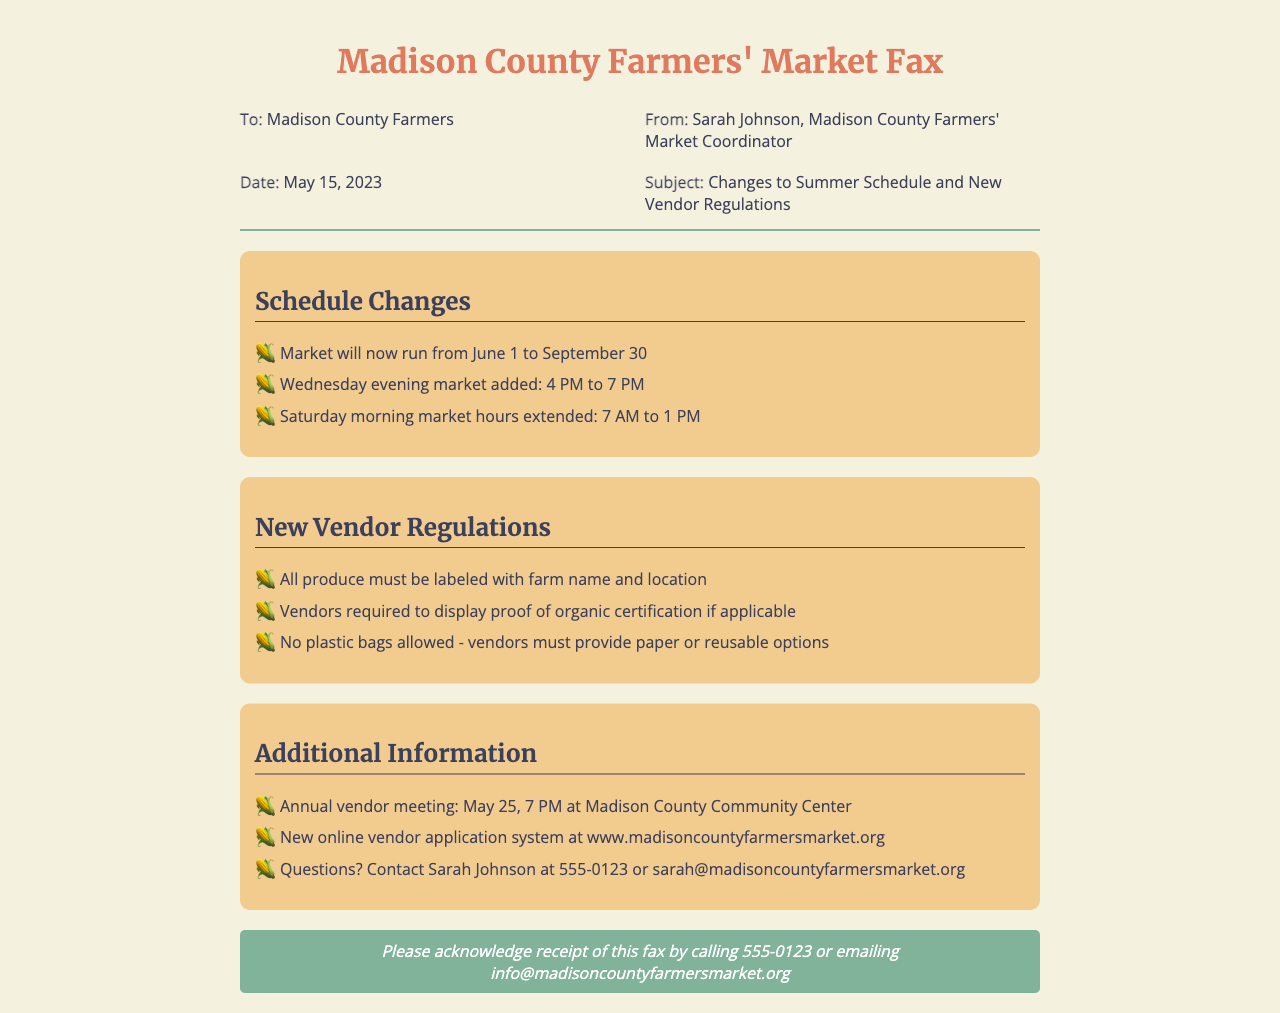What are the new market hours? The document states that the Saturday morning market hours are extended to 7 AM to 1 PM, and a Wednesday evening market is added from 4 PM to 7 PM.
Answer: 7 AM to 1 PM, 4 PM to 7 PM Who is the fax sent from? The document indicates that the fax is sent from Sarah Johnson, the Madison County Farmers' Market Coordinator.
Answer: Sarah Johnson When is the annual vendor meeting scheduled? The document provides the date for the annual vendor meeting as May 25, at 7 PM.
Answer: May 25, 7 PM What must vendors provide instead of plastic bags? The document specifies that vendors are required to provide paper or reusable options instead of plastic bags.
Answer: Paper or reusable options What is the website for the new vendor application system? The document indicates that the new online vendor application system can be found at www.madisoncountyfarmersmarket.org.
Answer: www.madisoncountyfarmersmarket.org What is the duration of the market operation? The fax states that the market will run from June 1 to September 30.
Answer: June 1 to September 30 What proof is required from vendors? The document mentions that vendors are required to display proof of organic certification if applicable.
Answer: Proof of organic certification What should be done to acknowledge receipt of the fax? The document states that one should acknowledge receipt by calling 555-0123 or emailing info@madisoncountyfarmersmarket.org.
Answer: Call 555-0123 or email info@madisoncountyfarmersmarket.org 